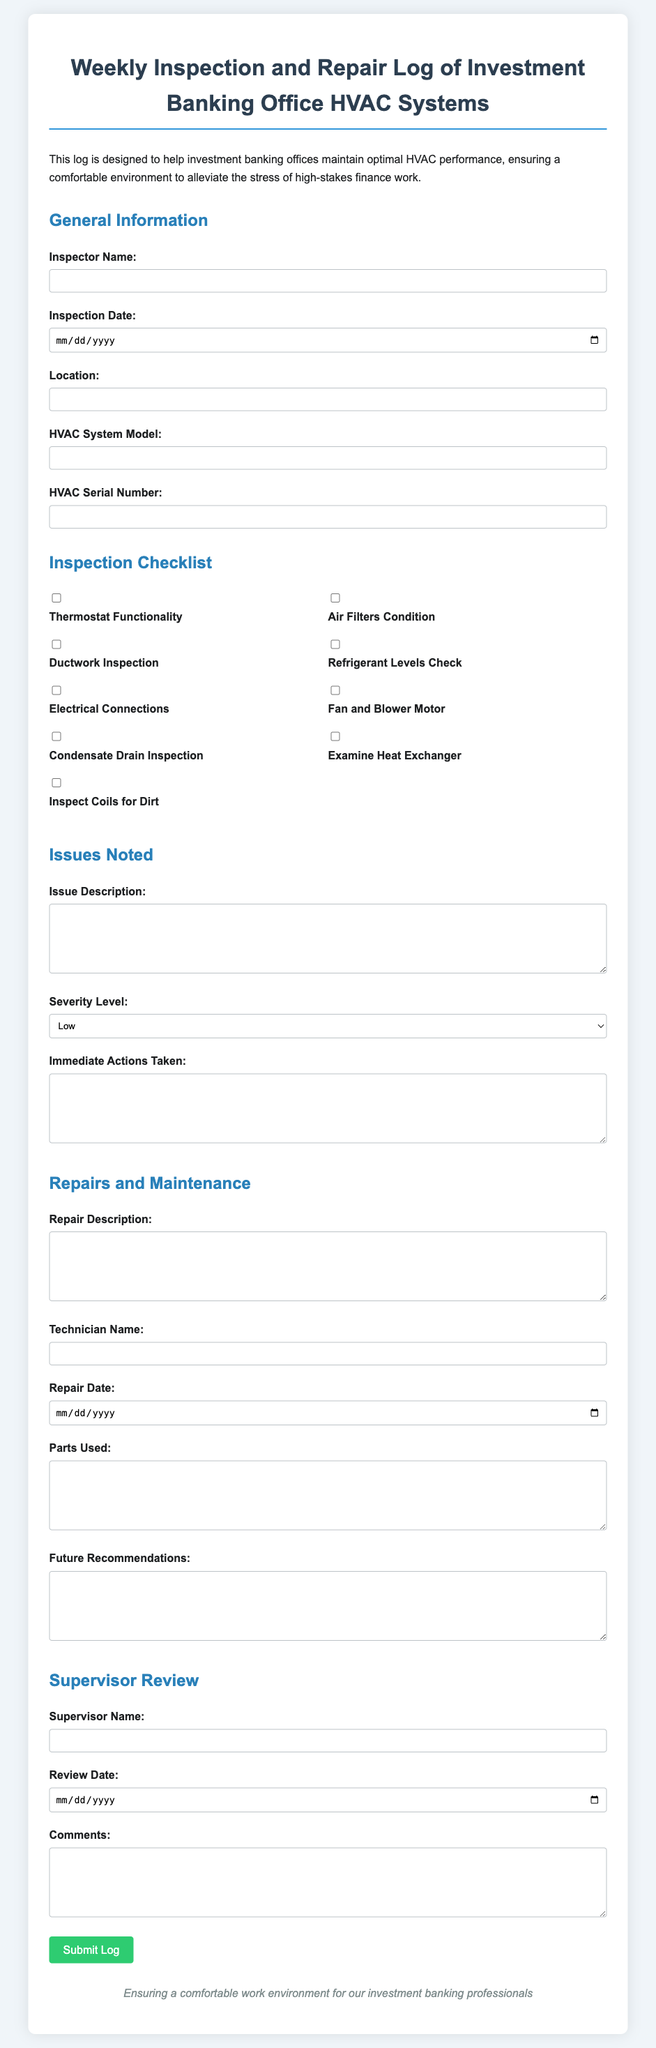What is the title of the document? The title of the document is clearly indicated at the top, which is "Weekly Inspection and Repair Log of Investment Banking Office HVAC Systems."
Answer: Weekly Inspection and Repair Log of Investment Banking Office HVAC Systems Who is responsible for the inspection? The inspector's name is requested in the form, which indicates that it will be filled out by the individual responsible for performing the inspection.
Answer: Inspector Name What date is the inspection conducted? The inspection date is a required field in the form, indicating when the inspection took place.
Answer: Inspection Date What severity levels are available for noting issues? The document provides a selection of severity levels for any issues noted during the inspection, which are Low, Medium, and High.
Answer: Low, Medium, High Which item checks the functionality of the HVAC? There are several checklist items, and one of them specifically addresses the functionality of the HVAC system, which is related to thermostat functionality.
Answer: Thermostat Functionality What must be filled in for repairs conducted? The form requests the technician's name as part of recording repairs conducted, which is essential information in this context.
Answer: Technician Name What section discusses future recommendations? There is a dedicated section in the form for noting future recommendations based on the inspection and repairs conducted.
Answer: Future Recommendations How is the log submitted? The log can be submitted using the designated button labeled "Submit Log" found at the bottom of the form.
Answer: Submit Log What is mentioned at the footer of the document? The footer contains a statement about ensuring a comfortable work environment for investment banking professionals, emphasizing the document's purpose.
Answer: Ensuring a comfortable work environment for our investment banking professionals 